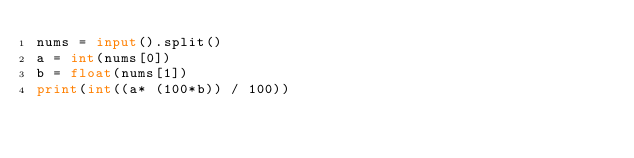Convert code to text. <code><loc_0><loc_0><loc_500><loc_500><_Python_>nums = input().split()
a = int(nums[0])
b = float(nums[1])
print(int((a* (100*b)) / 100))</code> 